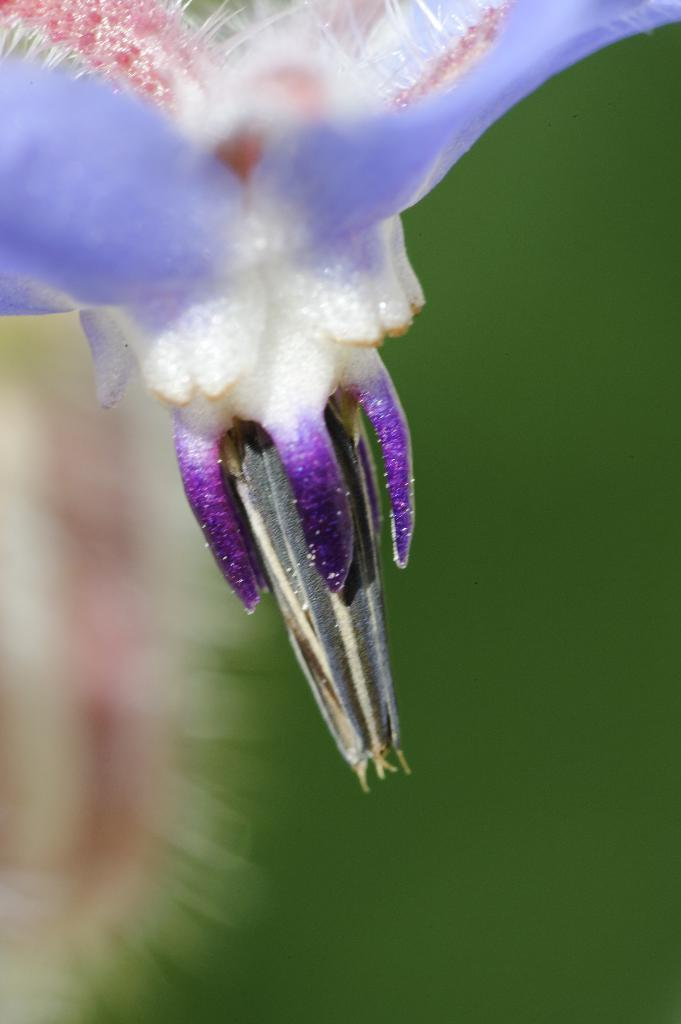What is the main subject of the picture? The main subject of the picture is a flower. Can you describe the colors of the flower? The flower has violet, pink, and white colors. What can be seen in the background of the picture? The background is green and blurred. How does the flower feel pain in the image? Flowers do not have the ability to feel pain, so this question is not applicable to the image. 